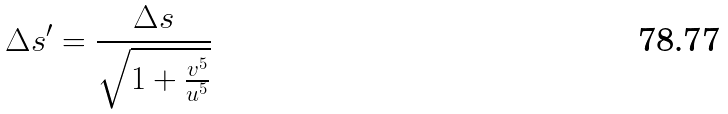<formula> <loc_0><loc_0><loc_500><loc_500>\Delta s ^ { \prime } = \frac { \Delta s } { \sqrt { 1 + \frac { v ^ { 5 } } { u ^ { 5 } } } }</formula> 